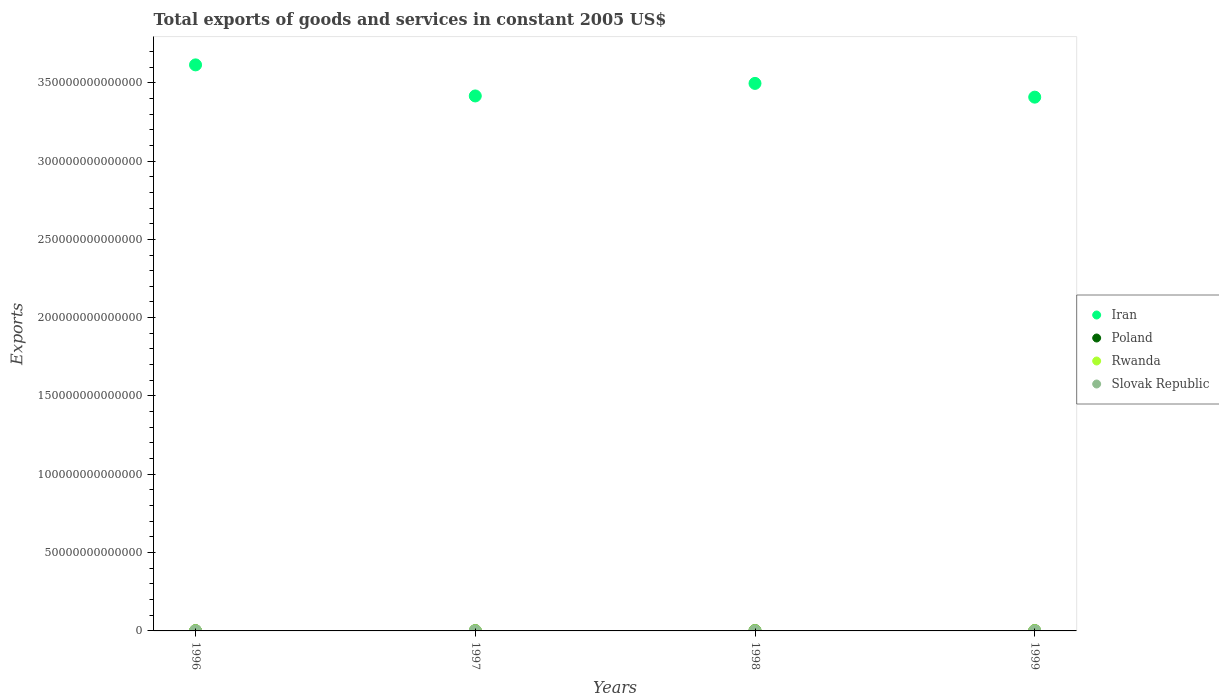How many different coloured dotlines are there?
Provide a short and direct response. 4. Is the number of dotlines equal to the number of legend labels?
Give a very brief answer. Yes. What is the total exports of goods and services in Iran in 1998?
Provide a succinct answer. 3.50e+14. Across all years, what is the maximum total exports of goods and services in Iran?
Give a very brief answer. 3.61e+14. Across all years, what is the minimum total exports of goods and services in Iran?
Your answer should be very brief. 3.41e+14. In which year was the total exports of goods and services in Rwanda maximum?
Your answer should be compact. 1999. What is the total total exports of goods and services in Rwanda in the graph?
Keep it short and to the point. 3.69e+11. What is the difference between the total exports of goods and services in Poland in 1996 and that in 1998?
Your answer should be compact. -4.47e+1. What is the difference between the total exports of goods and services in Slovak Republic in 1997 and the total exports of goods and services in Rwanda in 1999?
Your response must be concise. -9.51e+1. What is the average total exports of goods and services in Poland per year?
Keep it short and to the point. 1.83e+11. In the year 1996, what is the difference between the total exports of goods and services in Slovak Republic and total exports of goods and services in Iran?
Give a very brief answer. -3.61e+14. In how many years, is the total exports of goods and services in Rwanda greater than 260000000000000 US$?
Give a very brief answer. 0. What is the ratio of the total exports of goods and services in Iran in 1997 to that in 1998?
Your response must be concise. 0.98. Is the difference between the total exports of goods and services in Slovak Republic in 1996 and 1999 greater than the difference between the total exports of goods and services in Iran in 1996 and 1999?
Your response must be concise. No. What is the difference between the highest and the second highest total exports of goods and services in Iran?
Offer a very short reply. 1.18e+13. What is the difference between the highest and the lowest total exports of goods and services in Iran?
Give a very brief answer. 2.06e+13. In how many years, is the total exports of goods and services in Iran greater than the average total exports of goods and services in Iran taken over all years?
Ensure brevity in your answer.  2. Is the sum of the total exports of goods and services in Rwanda in 1996 and 1998 greater than the maximum total exports of goods and services in Iran across all years?
Provide a succinct answer. No. Is it the case that in every year, the sum of the total exports of goods and services in Poland and total exports of goods and services in Slovak Republic  is greater than the sum of total exports of goods and services in Iran and total exports of goods and services in Rwanda?
Ensure brevity in your answer.  No. How many dotlines are there?
Your answer should be very brief. 4. What is the difference between two consecutive major ticks on the Y-axis?
Provide a short and direct response. 5.00e+13. Are the values on the major ticks of Y-axis written in scientific E-notation?
Ensure brevity in your answer.  No. Does the graph contain any zero values?
Provide a short and direct response. No. Does the graph contain grids?
Your answer should be very brief. No. What is the title of the graph?
Keep it short and to the point. Total exports of goods and services in constant 2005 US$. What is the label or title of the Y-axis?
Your response must be concise. Exports. What is the Exports in Iran in 1996?
Your answer should be very brief. 3.61e+14. What is the Exports in Poland in 1996?
Offer a very short reply. 1.57e+11. What is the Exports of Rwanda in 1996?
Provide a succinct answer. 7.08e+1. What is the Exports in Slovak Republic in 1996?
Your answer should be compact. 1.52e+1. What is the Exports in Iran in 1997?
Ensure brevity in your answer.  3.42e+14. What is the Exports in Poland in 1997?
Your answer should be very brief. 1.76e+11. What is the Exports in Rwanda in 1997?
Ensure brevity in your answer.  9.23e+1. What is the Exports in Slovak Republic in 1997?
Provide a succinct answer. 1.67e+1. What is the Exports of Iran in 1998?
Offer a very short reply. 3.50e+14. What is the Exports in Poland in 1998?
Provide a succinct answer. 2.02e+11. What is the Exports in Rwanda in 1998?
Provide a succinct answer. 9.41e+1. What is the Exports in Slovak Republic in 1998?
Your answer should be compact. 1.63e+1. What is the Exports in Iran in 1999?
Provide a short and direct response. 3.41e+14. What is the Exports of Poland in 1999?
Ensure brevity in your answer.  1.97e+11. What is the Exports in Rwanda in 1999?
Your answer should be very brief. 1.12e+11. What is the Exports of Slovak Republic in 1999?
Provide a short and direct response. 1.79e+1. Across all years, what is the maximum Exports in Iran?
Provide a succinct answer. 3.61e+14. Across all years, what is the maximum Exports of Poland?
Offer a very short reply. 2.02e+11. Across all years, what is the maximum Exports in Rwanda?
Your answer should be very brief. 1.12e+11. Across all years, what is the maximum Exports of Slovak Republic?
Give a very brief answer. 1.79e+1. Across all years, what is the minimum Exports in Iran?
Keep it short and to the point. 3.41e+14. Across all years, what is the minimum Exports of Poland?
Your response must be concise. 1.57e+11. Across all years, what is the minimum Exports in Rwanda?
Make the answer very short. 7.08e+1. Across all years, what is the minimum Exports in Slovak Republic?
Offer a very short reply. 1.52e+1. What is the total Exports of Iran in the graph?
Provide a short and direct response. 1.39e+15. What is the total Exports in Poland in the graph?
Provide a succinct answer. 7.32e+11. What is the total Exports of Rwanda in the graph?
Offer a terse response. 3.69e+11. What is the total Exports of Slovak Republic in the graph?
Your answer should be compact. 6.62e+1. What is the difference between the Exports of Iran in 1996 and that in 1997?
Give a very brief answer. 1.98e+13. What is the difference between the Exports in Poland in 1996 and that in 1997?
Ensure brevity in your answer.  -1.92e+1. What is the difference between the Exports of Rwanda in 1996 and that in 1997?
Provide a short and direct response. -2.15e+1. What is the difference between the Exports in Slovak Republic in 1996 and that in 1997?
Keep it short and to the point. -1.52e+09. What is the difference between the Exports of Iran in 1996 and that in 1998?
Your answer should be very brief. 1.18e+13. What is the difference between the Exports of Poland in 1996 and that in 1998?
Keep it short and to the point. -4.47e+1. What is the difference between the Exports of Rwanda in 1996 and that in 1998?
Ensure brevity in your answer.  -2.33e+1. What is the difference between the Exports of Slovak Republic in 1996 and that in 1998?
Provide a succinct answer. -1.08e+09. What is the difference between the Exports in Iran in 1996 and that in 1999?
Provide a short and direct response. 2.06e+13. What is the difference between the Exports in Poland in 1996 and that in 1999?
Provide a succinct answer. -3.96e+1. What is the difference between the Exports of Rwanda in 1996 and that in 1999?
Give a very brief answer. -4.10e+1. What is the difference between the Exports of Slovak Republic in 1996 and that in 1999?
Your response must be concise. -2.73e+09. What is the difference between the Exports in Iran in 1997 and that in 1998?
Make the answer very short. -8.01e+12. What is the difference between the Exports of Poland in 1997 and that in 1998?
Your response must be concise. -2.54e+1. What is the difference between the Exports of Rwanda in 1997 and that in 1998?
Your answer should be compact. -1.75e+09. What is the difference between the Exports of Slovak Republic in 1997 and that in 1998?
Provide a succinct answer. 4.37e+08. What is the difference between the Exports in Iran in 1997 and that in 1999?
Ensure brevity in your answer.  7.65e+11. What is the difference between the Exports in Poland in 1997 and that in 1999?
Make the answer very short. -2.04e+1. What is the difference between the Exports in Rwanda in 1997 and that in 1999?
Your answer should be very brief. -1.95e+1. What is the difference between the Exports of Slovak Republic in 1997 and that in 1999?
Your answer should be compact. -1.21e+09. What is the difference between the Exports of Iran in 1998 and that in 1999?
Your answer should be compact. 8.78e+12. What is the difference between the Exports in Poland in 1998 and that in 1999?
Offer a terse response. 5.07e+09. What is the difference between the Exports in Rwanda in 1998 and that in 1999?
Your answer should be compact. -1.77e+1. What is the difference between the Exports of Slovak Republic in 1998 and that in 1999?
Ensure brevity in your answer.  -1.65e+09. What is the difference between the Exports in Iran in 1996 and the Exports in Poland in 1997?
Ensure brevity in your answer.  3.61e+14. What is the difference between the Exports of Iran in 1996 and the Exports of Rwanda in 1997?
Offer a very short reply. 3.61e+14. What is the difference between the Exports of Iran in 1996 and the Exports of Slovak Republic in 1997?
Your answer should be very brief. 3.61e+14. What is the difference between the Exports in Poland in 1996 and the Exports in Rwanda in 1997?
Offer a very short reply. 6.48e+1. What is the difference between the Exports in Poland in 1996 and the Exports in Slovak Republic in 1997?
Ensure brevity in your answer.  1.40e+11. What is the difference between the Exports in Rwanda in 1996 and the Exports in Slovak Republic in 1997?
Provide a short and direct response. 5.40e+1. What is the difference between the Exports of Iran in 1996 and the Exports of Poland in 1998?
Keep it short and to the point. 3.61e+14. What is the difference between the Exports in Iran in 1996 and the Exports in Rwanda in 1998?
Ensure brevity in your answer.  3.61e+14. What is the difference between the Exports of Iran in 1996 and the Exports of Slovak Republic in 1998?
Give a very brief answer. 3.61e+14. What is the difference between the Exports of Poland in 1996 and the Exports of Rwanda in 1998?
Your response must be concise. 6.30e+1. What is the difference between the Exports of Poland in 1996 and the Exports of Slovak Republic in 1998?
Give a very brief answer. 1.41e+11. What is the difference between the Exports of Rwanda in 1996 and the Exports of Slovak Republic in 1998?
Ensure brevity in your answer.  5.45e+1. What is the difference between the Exports of Iran in 1996 and the Exports of Poland in 1999?
Your answer should be compact. 3.61e+14. What is the difference between the Exports of Iran in 1996 and the Exports of Rwanda in 1999?
Ensure brevity in your answer.  3.61e+14. What is the difference between the Exports in Iran in 1996 and the Exports in Slovak Republic in 1999?
Offer a very short reply. 3.61e+14. What is the difference between the Exports in Poland in 1996 and the Exports in Rwanda in 1999?
Provide a succinct answer. 4.53e+1. What is the difference between the Exports in Poland in 1996 and the Exports in Slovak Republic in 1999?
Ensure brevity in your answer.  1.39e+11. What is the difference between the Exports of Rwanda in 1996 and the Exports of Slovak Republic in 1999?
Your answer should be compact. 5.28e+1. What is the difference between the Exports of Iran in 1997 and the Exports of Poland in 1998?
Keep it short and to the point. 3.41e+14. What is the difference between the Exports in Iran in 1997 and the Exports in Rwanda in 1998?
Keep it short and to the point. 3.41e+14. What is the difference between the Exports of Iran in 1997 and the Exports of Slovak Republic in 1998?
Your answer should be compact. 3.42e+14. What is the difference between the Exports of Poland in 1997 and the Exports of Rwanda in 1998?
Your answer should be compact. 8.22e+1. What is the difference between the Exports in Poland in 1997 and the Exports in Slovak Republic in 1998?
Give a very brief answer. 1.60e+11. What is the difference between the Exports in Rwanda in 1997 and the Exports in Slovak Republic in 1998?
Make the answer very short. 7.60e+1. What is the difference between the Exports in Iran in 1997 and the Exports in Poland in 1999?
Make the answer very short. 3.41e+14. What is the difference between the Exports of Iran in 1997 and the Exports of Rwanda in 1999?
Your answer should be very brief. 3.41e+14. What is the difference between the Exports of Iran in 1997 and the Exports of Slovak Republic in 1999?
Make the answer very short. 3.42e+14. What is the difference between the Exports in Poland in 1997 and the Exports in Rwanda in 1999?
Your answer should be compact. 6.45e+1. What is the difference between the Exports in Poland in 1997 and the Exports in Slovak Republic in 1999?
Your answer should be very brief. 1.58e+11. What is the difference between the Exports of Rwanda in 1997 and the Exports of Slovak Republic in 1999?
Your response must be concise. 7.44e+1. What is the difference between the Exports of Iran in 1998 and the Exports of Poland in 1999?
Ensure brevity in your answer.  3.49e+14. What is the difference between the Exports of Iran in 1998 and the Exports of Rwanda in 1999?
Ensure brevity in your answer.  3.49e+14. What is the difference between the Exports of Iran in 1998 and the Exports of Slovak Republic in 1999?
Provide a succinct answer. 3.50e+14. What is the difference between the Exports in Poland in 1998 and the Exports in Rwanda in 1999?
Provide a succinct answer. 8.99e+1. What is the difference between the Exports in Poland in 1998 and the Exports in Slovak Republic in 1999?
Make the answer very short. 1.84e+11. What is the difference between the Exports of Rwanda in 1998 and the Exports of Slovak Republic in 1999?
Make the answer very short. 7.61e+1. What is the average Exports of Iran per year?
Give a very brief answer. 3.48e+14. What is the average Exports in Poland per year?
Ensure brevity in your answer.  1.83e+11. What is the average Exports of Rwanda per year?
Offer a terse response. 9.22e+1. What is the average Exports of Slovak Republic per year?
Give a very brief answer. 1.65e+1. In the year 1996, what is the difference between the Exports of Iran and Exports of Poland?
Provide a succinct answer. 3.61e+14. In the year 1996, what is the difference between the Exports in Iran and Exports in Rwanda?
Your answer should be very brief. 3.61e+14. In the year 1996, what is the difference between the Exports in Iran and Exports in Slovak Republic?
Make the answer very short. 3.61e+14. In the year 1996, what is the difference between the Exports of Poland and Exports of Rwanda?
Offer a terse response. 8.63e+1. In the year 1996, what is the difference between the Exports of Poland and Exports of Slovak Republic?
Ensure brevity in your answer.  1.42e+11. In the year 1996, what is the difference between the Exports of Rwanda and Exports of Slovak Republic?
Offer a very short reply. 5.56e+1. In the year 1997, what is the difference between the Exports of Iran and Exports of Poland?
Offer a terse response. 3.41e+14. In the year 1997, what is the difference between the Exports of Iran and Exports of Rwanda?
Offer a terse response. 3.41e+14. In the year 1997, what is the difference between the Exports of Iran and Exports of Slovak Republic?
Your answer should be compact. 3.42e+14. In the year 1997, what is the difference between the Exports in Poland and Exports in Rwanda?
Offer a terse response. 8.40e+1. In the year 1997, what is the difference between the Exports of Poland and Exports of Slovak Republic?
Keep it short and to the point. 1.60e+11. In the year 1997, what is the difference between the Exports of Rwanda and Exports of Slovak Republic?
Offer a very short reply. 7.56e+1. In the year 1998, what is the difference between the Exports of Iran and Exports of Poland?
Offer a very short reply. 3.49e+14. In the year 1998, what is the difference between the Exports of Iran and Exports of Rwanda?
Your answer should be compact. 3.49e+14. In the year 1998, what is the difference between the Exports in Iran and Exports in Slovak Republic?
Your answer should be very brief. 3.50e+14. In the year 1998, what is the difference between the Exports in Poland and Exports in Rwanda?
Offer a terse response. 1.08e+11. In the year 1998, what is the difference between the Exports of Poland and Exports of Slovak Republic?
Ensure brevity in your answer.  1.85e+11. In the year 1998, what is the difference between the Exports of Rwanda and Exports of Slovak Republic?
Your response must be concise. 7.78e+1. In the year 1999, what is the difference between the Exports in Iran and Exports in Poland?
Provide a succinct answer. 3.41e+14. In the year 1999, what is the difference between the Exports in Iran and Exports in Rwanda?
Your answer should be very brief. 3.41e+14. In the year 1999, what is the difference between the Exports in Iran and Exports in Slovak Republic?
Give a very brief answer. 3.41e+14. In the year 1999, what is the difference between the Exports of Poland and Exports of Rwanda?
Ensure brevity in your answer.  8.49e+1. In the year 1999, what is the difference between the Exports in Poland and Exports in Slovak Republic?
Provide a short and direct response. 1.79e+11. In the year 1999, what is the difference between the Exports of Rwanda and Exports of Slovak Republic?
Make the answer very short. 9.39e+1. What is the ratio of the Exports of Iran in 1996 to that in 1997?
Your answer should be compact. 1.06. What is the ratio of the Exports in Poland in 1996 to that in 1997?
Offer a very short reply. 0.89. What is the ratio of the Exports in Rwanda in 1996 to that in 1997?
Your answer should be very brief. 0.77. What is the ratio of the Exports in Slovak Republic in 1996 to that in 1997?
Your answer should be compact. 0.91. What is the ratio of the Exports of Iran in 1996 to that in 1998?
Offer a terse response. 1.03. What is the ratio of the Exports in Poland in 1996 to that in 1998?
Your response must be concise. 0.78. What is the ratio of the Exports in Rwanda in 1996 to that in 1998?
Provide a succinct answer. 0.75. What is the ratio of the Exports in Slovak Republic in 1996 to that in 1998?
Provide a succinct answer. 0.93. What is the ratio of the Exports of Iran in 1996 to that in 1999?
Ensure brevity in your answer.  1.06. What is the ratio of the Exports in Poland in 1996 to that in 1999?
Your answer should be very brief. 0.8. What is the ratio of the Exports of Rwanda in 1996 to that in 1999?
Your response must be concise. 0.63. What is the ratio of the Exports of Slovak Republic in 1996 to that in 1999?
Provide a succinct answer. 0.85. What is the ratio of the Exports in Iran in 1997 to that in 1998?
Keep it short and to the point. 0.98. What is the ratio of the Exports of Poland in 1997 to that in 1998?
Your answer should be very brief. 0.87. What is the ratio of the Exports of Rwanda in 1997 to that in 1998?
Make the answer very short. 0.98. What is the ratio of the Exports of Slovak Republic in 1997 to that in 1998?
Ensure brevity in your answer.  1.03. What is the ratio of the Exports of Iran in 1997 to that in 1999?
Your answer should be compact. 1. What is the ratio of the Exports of Poland in 1997 to that in 1999?
Offer a terse response. 0.9. What is the ratio of the Exports in Rwanda in 1997 to that in 1999?
Ensure brevity in your answer.  0.83. What is the ratio of the Exports in Slovak Republic in 1997 to that in 1999?
Your answer should be very brief. 0.93. What is the ratio of the Exports in Iran in 1998 to that in 1999?
Make the answer very short. 1.03. What is the ratio of the Exports in Poland in 1998 to that in 1999?
Offer a terse response. 1.03. What is the ratio of the Exports of Rwanda in 1998 to that in 1999?
Offer a terse response. 0.84. What is the ratio of the Exports in Slovak Republic in 1998 to that in 1999?
Offer a terse response. 0.91. What is the difference between the highest and the second highest Exports of Iran?
Offer a very short reply. 1.18e+13. What is the difference between the highest and the second highest Exports in Poland?
Keep it short and to the point. 5.07e+09. What is the difference between the highest and the second highest Exports of Rwanda?
Keep it short and to the point. 1.77e+1. What is the difference between the highest and the second highest Exports in Slovak Republic?
Your answer should be compact. 1.21e+09. What is the difference between the highest and the lowest Exports of Iran?
Your response must be concise. 2.06e+13. What is the difference between the highest and the lowest Exports in Poland?
Your response must be concise. 4.47e+1. What is the difference between the highest and the lowest Exports of Rwanda?
Ensure brevity in your answer.  4.10e+1. What is the difference between the highest and the lowest Exports of Slovak Republic?
Your answer should be compact. 2.73e+09. 